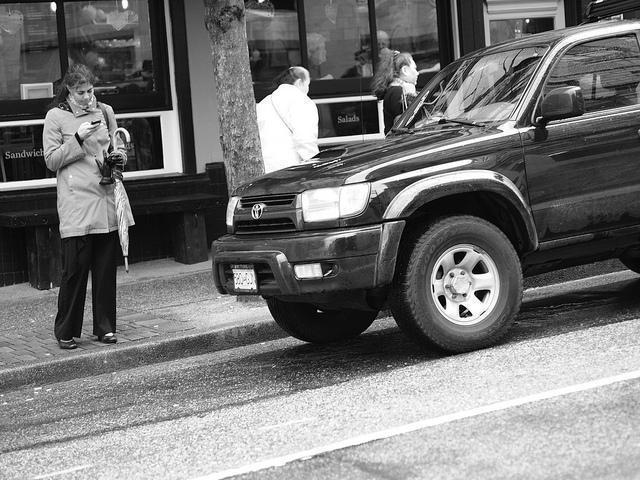Why is the woman looking down into her hand?
Indicate the correct response by choosing from the four available options to answer the question.
Options: She's frantic, she's embarrassed, she's crying, answering text. Answering text. Which automotive manufacturer made the jeep?
Select the correct answer and articulate reasoning with the following format: 'Answer: answer
Rationale: rationale.'
Options: Kia, honda, toyota, hyundai. Answer: toyota.
Rationale: Toyota constructed the jeep. 